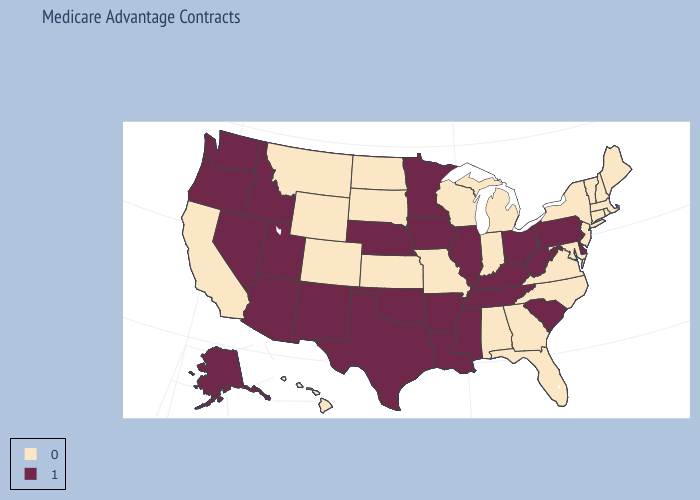Which states have the highest value in the USA?
Be succinct. Alaska, Arkansas, Arizona, Delaware, Iowa, Idaho, Illinois, Kentucky, Louisiana, Minnesota, Mississippi, Nebraska, New Mexico, Nevada, Ohio, Oklahoma, Oregon, Pennsylvania, South Carolina, Tennessee, Texas, Utah, Washington, West Virginia. Which states have the highest value in the USA?
Be succinct. Alaska, Arkansas, Arizona, Delaware, Iowa, Idaho, Illinois, Kentucky, Louisiana, Minnesota, Mississippi, Nebraska, New Mexico, Nevada, Ohio, Oklahoma, Oregon, Pennsylvania, South Carolina, Tennessee, Texas, Utah, Washington, West Virginia. Does Vermont have the lowest value in the USA?
Write a very short answer. Yes. What is the lowest value in the South?
Keep it brief. 0. Does Kentucky have the lowest value in the South?
Quick response, please. No. Does the first symbol in the legend represent the smallest category?
Answer briefly. Yes. Does the map have missing data?
Quick response, please. No. How many symbols are there in the legend?
Short answer required. 2. What is the highest value in the USA?
Write a very short answer. 1. Name the states that have a value in the range 1?
Keep it brief. Alaska, Arkansas, Arizona, Delaware, Iowa, Idaho, Illinois, Kentucky, Louisiana, Minnesota, Mississippi, Nebraska, New Mexico, Nevada, Ohio, Oklahoma, Oregon, Pennsylvania, South Carolina, Tennessee, Texas, Utah, Washington, West Virginia. Is the legend a continuous bar?
Short answer required. No. What is the value of Nevada?
Write a very short answer. 1. What is the value of Georgia?
Write a very short answer. 0. Name the states that have a value in the range 0?
Write a very short answer. Alabama, California, Colorado, Connecticut, Florida, Georgia, Hawaii, Indiana, Kansas, Massachusetts, Maryland, Maine, Michigan, Missouri, Montana, North Carolina, North Dakota, New Hampshire, New Jersey, New York, Rhode Island, South Dakota, Virginia, Vermont, Wisconsin, Wyoming. 